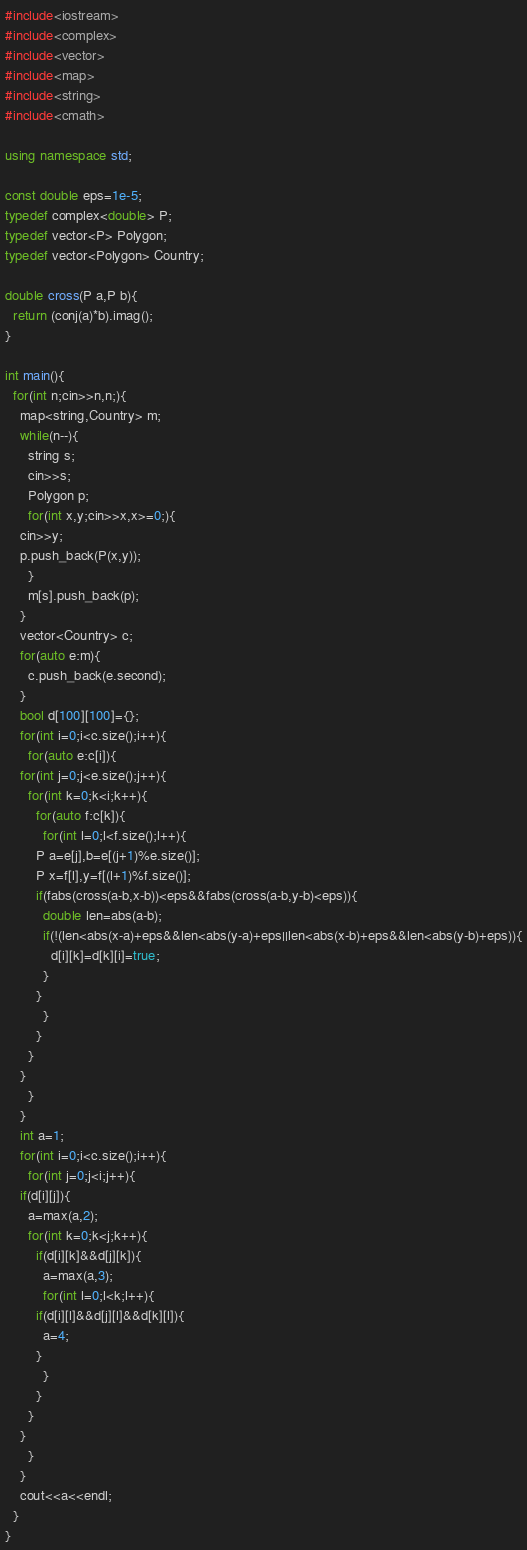<code> <loc_0><loc_0><loc_500><loc_500><_C++_>#include<iostream>
#include<complex>
#include<vector>
#include<map>
#include<string>
#include<cmath>

using namespace std;

const double eps=1e-5;
typedef complex<double> P;
typedef vector<P> Polygon;
typedef vector<Polygon> Country;

double cross(P a,P b){
  return (conj(a)*b).imag();
}

int main(){
  for(int n;cin>>n,n;){
    map<string,Country> m;
    while(n--){
      string s;
      cin>>s;
      Polygon p;
      for(int x,y;cin>>x,x>=0;){
	cin>>y;
	p.push_back(P(x,y));
      }
      m[s].push_back(p);
    }
    vector<Country> c;
    for(auto e:m){
      c.push_back(e.second);
    }
    bool d[100][100]={};
    for(int i=0;i<c.size();i++){
      for(auto e:c[i]){
	for(int j=0;j<e.size();j++){
	  for(int k=0;k<i;k++){
	    for(auto f:c[k]){
	      for(int l=0;l<f.size();l++){
		P a=e[j],b=e[(j+1)%e.size()];
		P x=f[l],y=f[(l+1)%f.size()];
		if(fabs(cross(a-b,x-b))<eps&&fabs(cross(a-b,y-b)<eps)){
		  double len=abs(a-b);
		  if(!(len<abs(x-a)+eps&&len<abs(y-a)+eps||len<abs(x-b)+eps&&len<abs(y-b)+eps)){
		    d[i][k]=d[k][i]=true;
		  }
		}
	      }
	    }
	  }
	}
      }
    }
    int a=1;
    for(int i=0;i<c.size();i++){
      for(int j=0;j<i;j++){
	if(d[i][j]){
	  a=max(a,2);
	  for(int k=0;k<j;k++){
	    if(d[i][k]&&d[j][k]){
	      a=max(a,3);
	      for(int l=0;l<k;l++){
		if(d[i][l]&&d[j][l]&&d[k][l]){
		  a=4;
		}
	      }
	    }
	  }
	}
      }
    }
    cout<<a<<endl;
  }
}</code> 